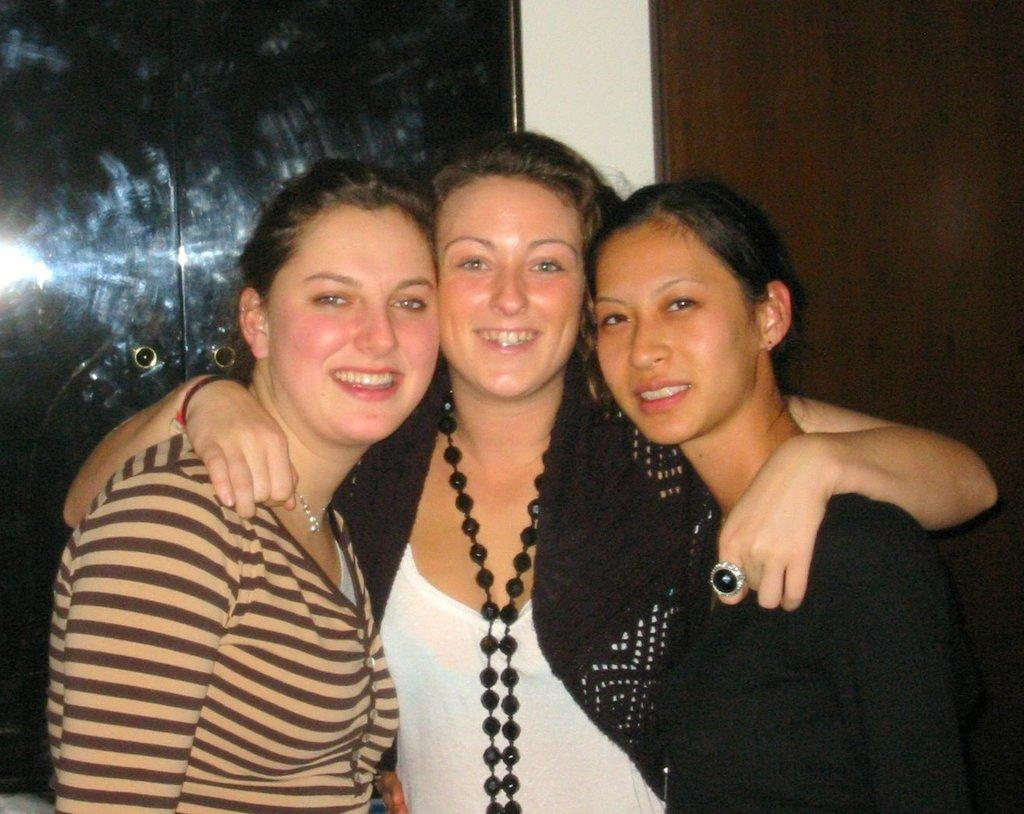What is the main subject of the image? There is a beautiful girl in the image. What is the girl doing in the image? The girl is smiling. What is the girl wearing in the image? The girl is wearing a white and black color dress. Are there any other people in the image? Yes, there are two other girls standing on either side of her. Can you tell me how many times the girl sneezes in the image? There is no indication of the girl sneezing in the image; she is simply smiling. What type of gate can be seen in the background of the image? There is no gate present in the image; it features a beautiful girl and two other girls. 